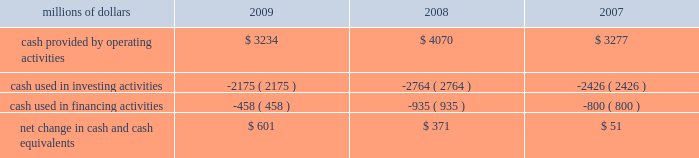Have access to liquidity by issuing bonds to public or private investors based on our assessment of the current condition of the credit markets .
At december 31 , 2009 , we had a working capital surplus of approximately $ 1.0 billion , which reflects our decision to maintain additional cash reserves to enhance liquidity in response to difficult economic conditions .
At december 31 , 2008 , we had a working capital deficit of approximately $ 100 million .
Historically , we have had a working capital deficit , which is common in our industry and does not indicate a lack of liquidity .
We maintain adequate resources and , when necessary , have access to capital to meet any daily and short-term cash requirements , and we have sufficient financial capacity to satisfy our current liabilities .
Cash flows millions of dollars 2009 2008 2007 .
Operating activities lower net income in 2009 , a reduction of $ 184 million in the outstanding balance of our accounts receivable securitization program , higher pension contributions of $ 72 million , and changes to working capital combined to decrease cash provided by operating activities compared to 2008 .
Higher net income and changes in working capital combined to increase cash provided by operating activities in 2008 compared to 2007 .
In addition , accelerated tax deductions enacted in 2008 on certain new operating assets resulted in lower income tax payments in 2008 versus 2007 .
Voluntary pension contributions in 2008 totaling $ 200 million and other pension contributions of $ 8 million partially offset the year-over-year increase versus 2007 .
Investing activities lower capital investments and higher proceeds from asset sales drove the decrease in cash used in investing activities in 2009 versus 2008 .
Increased capital investments and lower proceeds from asset sales drove the increase in cash used in investing activities in 2008 compared to 2007. .
What was the percentage change in cash provided by operating activities from 2007 to 2008? 
Computations: ((4070 - 3277) / 3277)
Answer: 0.24199. 